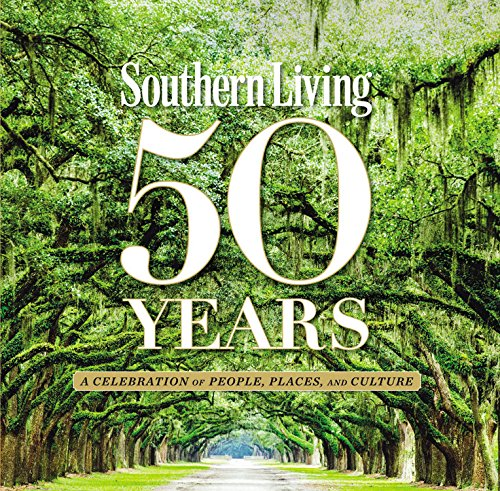What is the title of this book? The title of this rich volume is 'Southern Living 50 Years: A Celebration of People, Places, and Culture,' capturing half a century of Southern traditions and hospitality. 